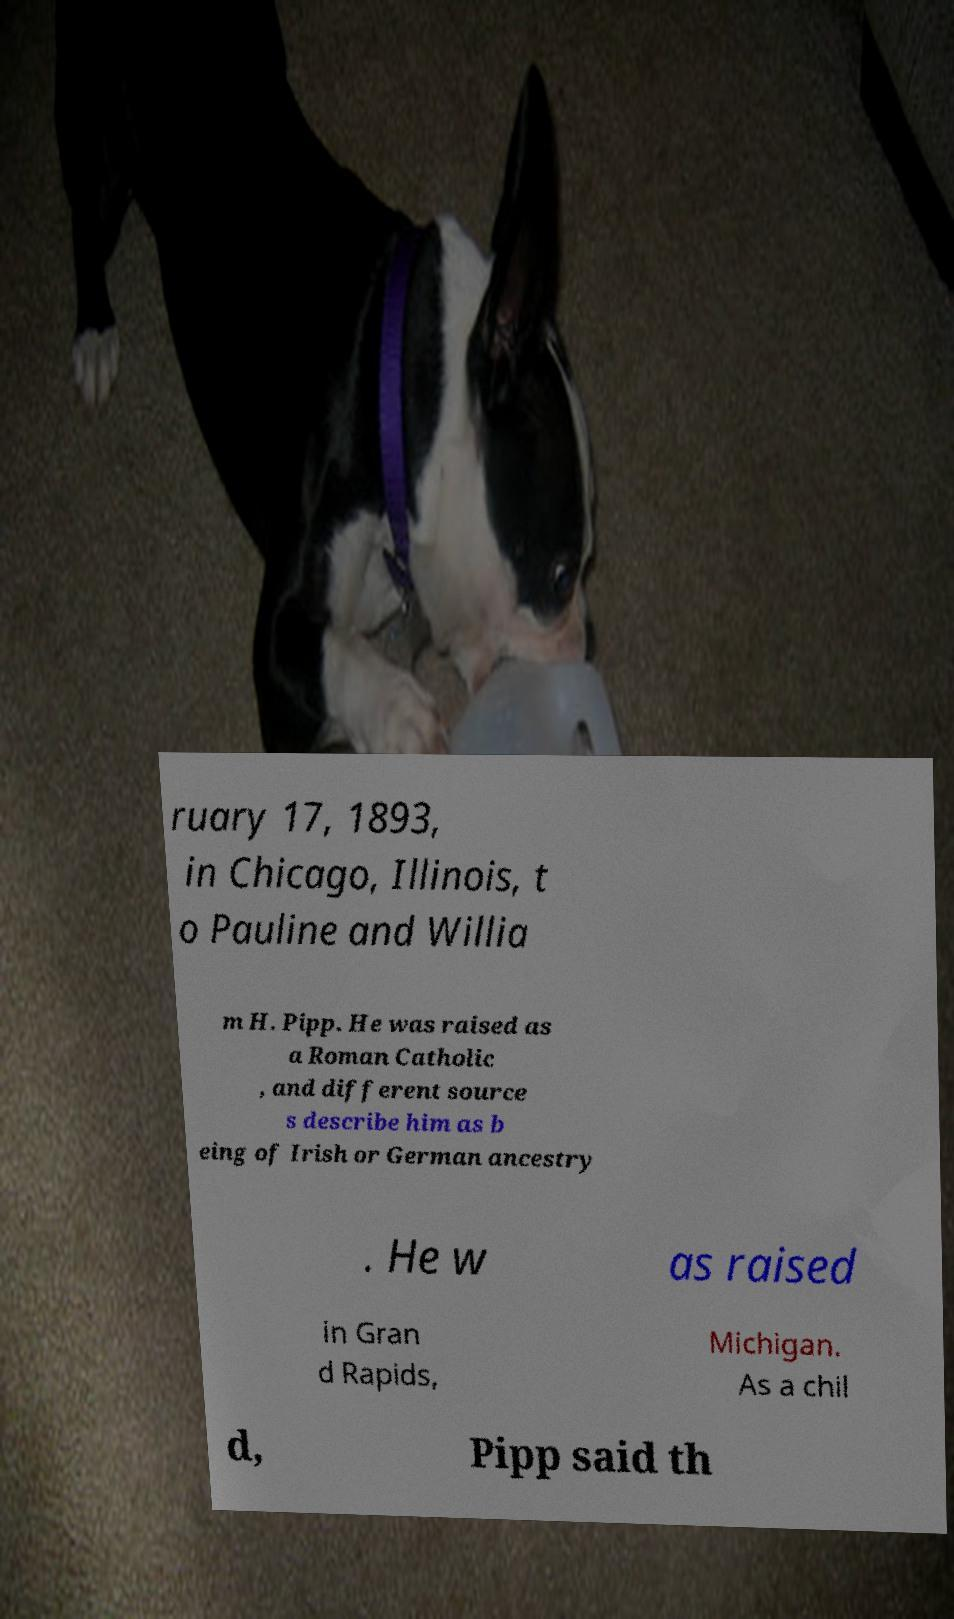There's text embedded in this image that I need extracted. Can you transcribe it verbatim? ruary 17, 1893, in Chicago, Illinois, t o Pauline and Willia m H. Pipp. He was raised as a Roman Catholic , and different source s describe him as b eing of Irish or German ancestry . He w as raised in Gran d Rapids, Michigan. As a chil d, Pipp said th 